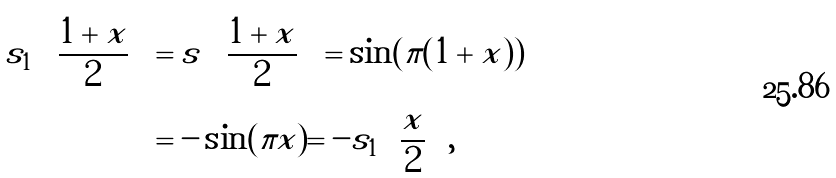Convert formula to latex. <formula><loc_0><loc_0><loc_500><loc_500>s _ { 1 } \left ( \frac { 1 + x } { 2 } \right ) & = s \left ( \frac { 1 + x } { 2 } \right ) = \sin ( \pi ( 1 + x ) ) \\ & = - \sin ( \pi x ) = - s _ { 1 } \left ( \frac { x } { 2 } \right ) ,</formula> 